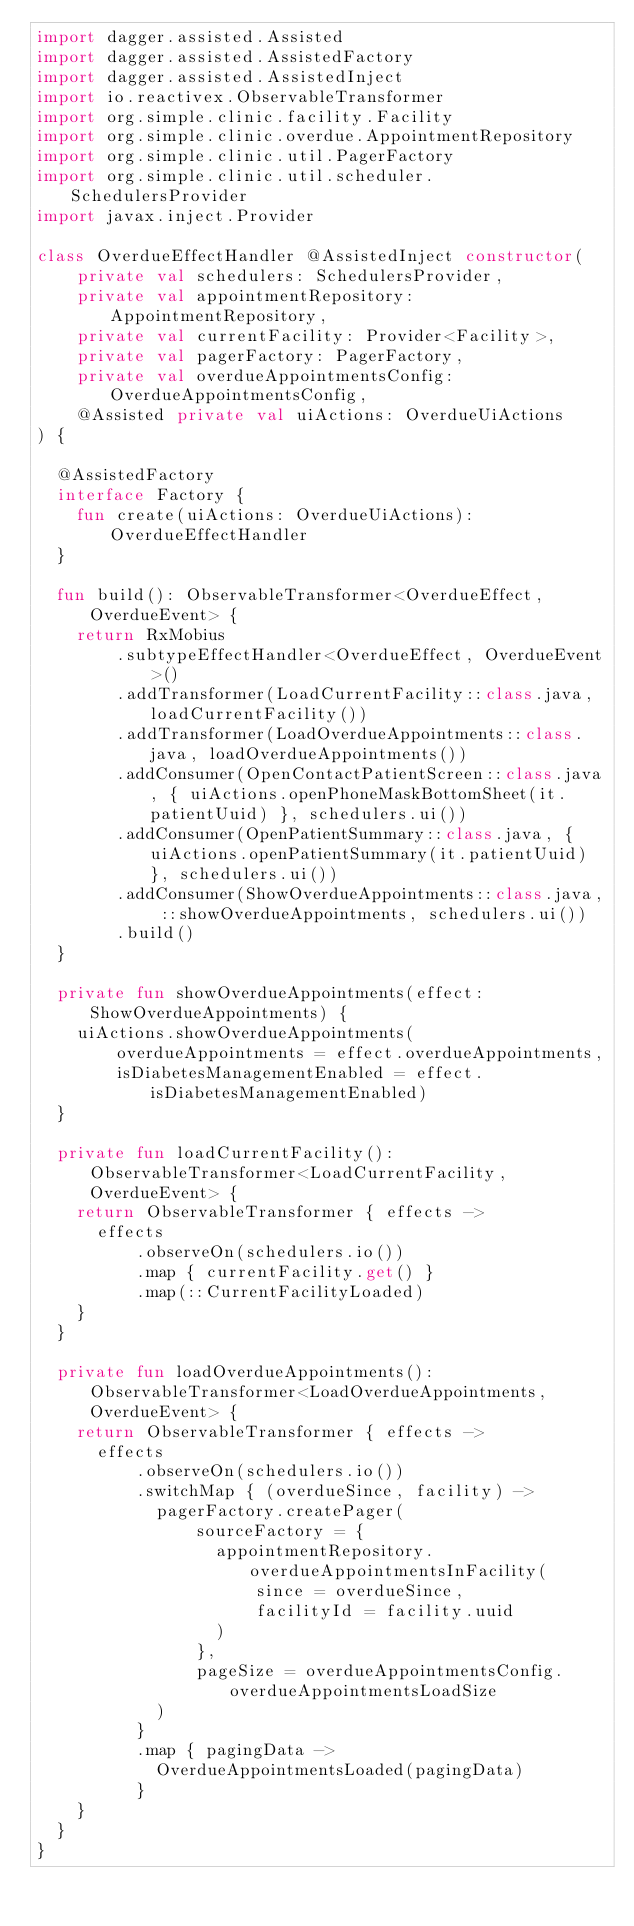Convert code to text. <code><loc_0><loc_0><loc_500><loc_500><_Kotlin_>import dagger.assisted.Assisted
import dagger.assisted.AssistedFactory
import dagger.assisted.AssistedInject
import io.reactivex.ObservableTransformer
import org.simple.clinic.facility.Facility
import org.simple.clinic.overdue.AppointmentRepository
import org.simple.clinic.util.PagerFactory
import org.simple.clinic.util.scheduler.SchedulersProvider
import javax.inject.Provider

class OverdueEffectHandler @AssistedInject constructor(
    private val schedulers: SchedulersProvider,
    private val appointmentRepository: AppointmentRepository,
    private val currentFacility: Provider<Facility>,
    private val pagerFactory: PagerFactory,
    private val overdueAppointmentsConfig: OverdueAppointmentsConfig,
    @Assisted private val uiActions: OverdueUiActions
) {

  @AssistedFactory
  interface Factory {
    fun create(uiActions: OverdueUiActions): OverdueEffectHandler
  }

  fun build(): ObservableTransformer<OverdueEffect, OverdueEvent> {
    return RxMobius
        .subtypeEffectHandler<OverdueEffect, OverdueEvent>()
        .addTransformer(LoadCurrentFacility::class.java, loadCurrentFacility())
        .addTransformer(LoadOverdueAppointments::class.java, loadOverdueAppointments())
        .addConsumer(OpenContactPatientScreen::class.java, { uiActions.openPhoneMaskBottomSheet(it.patientUuid) }, schedulers.ui())
        .addConsumer(OpenPatientSummary::class.java, { uiActions.openPatientSummary(it.patientUuid) }, schedulers.ui())
        .addConsumer(ShowOverdueAppointments::class.java, ::showOverdueAppointments, schedulers.ui())
        .build()
  }

  private fun showOverdueAppointments(effect: ShowOverdueAppointments) {
    uiActions.showOverdueAppointments(
        overdueAppointments = effect.overdueAppointments,
        isDiabetesManagementEnabled = effect.isDiabetesManagementEnabled)
  }

  private fun loadCurrentFacility(): ObservableTransformer<LoadCurrentFacility, OverdueEvent> {
    return ObservableTransformer { effects ->
      effects
          .observeOn(schedulers.io())
          .map { currentFacility.get() }
          .map(::CurrentFacilityLoaded)
    }
  }

  private fun loadOverdueAppointments(): ObservableTransformer<LoadOverdueAppointments, OverdueEvent> {
    return ObservableTransformer { effects ->
      effects
          .observeOn(schedulers.io())
          .switchMap { (overdueSince, facility) ->
            pagerFactory.createPager(
                sourceFactory = {
                  appointmentRepository.overdueAppointmentsInFacility(
                      since = overdueSince,
                      facilityId = facility.uuid
                  )
                },
                pageSize = overdueAppointmentsConfig.overdueAppointmentsLoadSize
            )
          }
          .map { pagingData ->
            OverdueAppointmentsLoaded(pagingData)
          }
    }
  }
}
</code> 